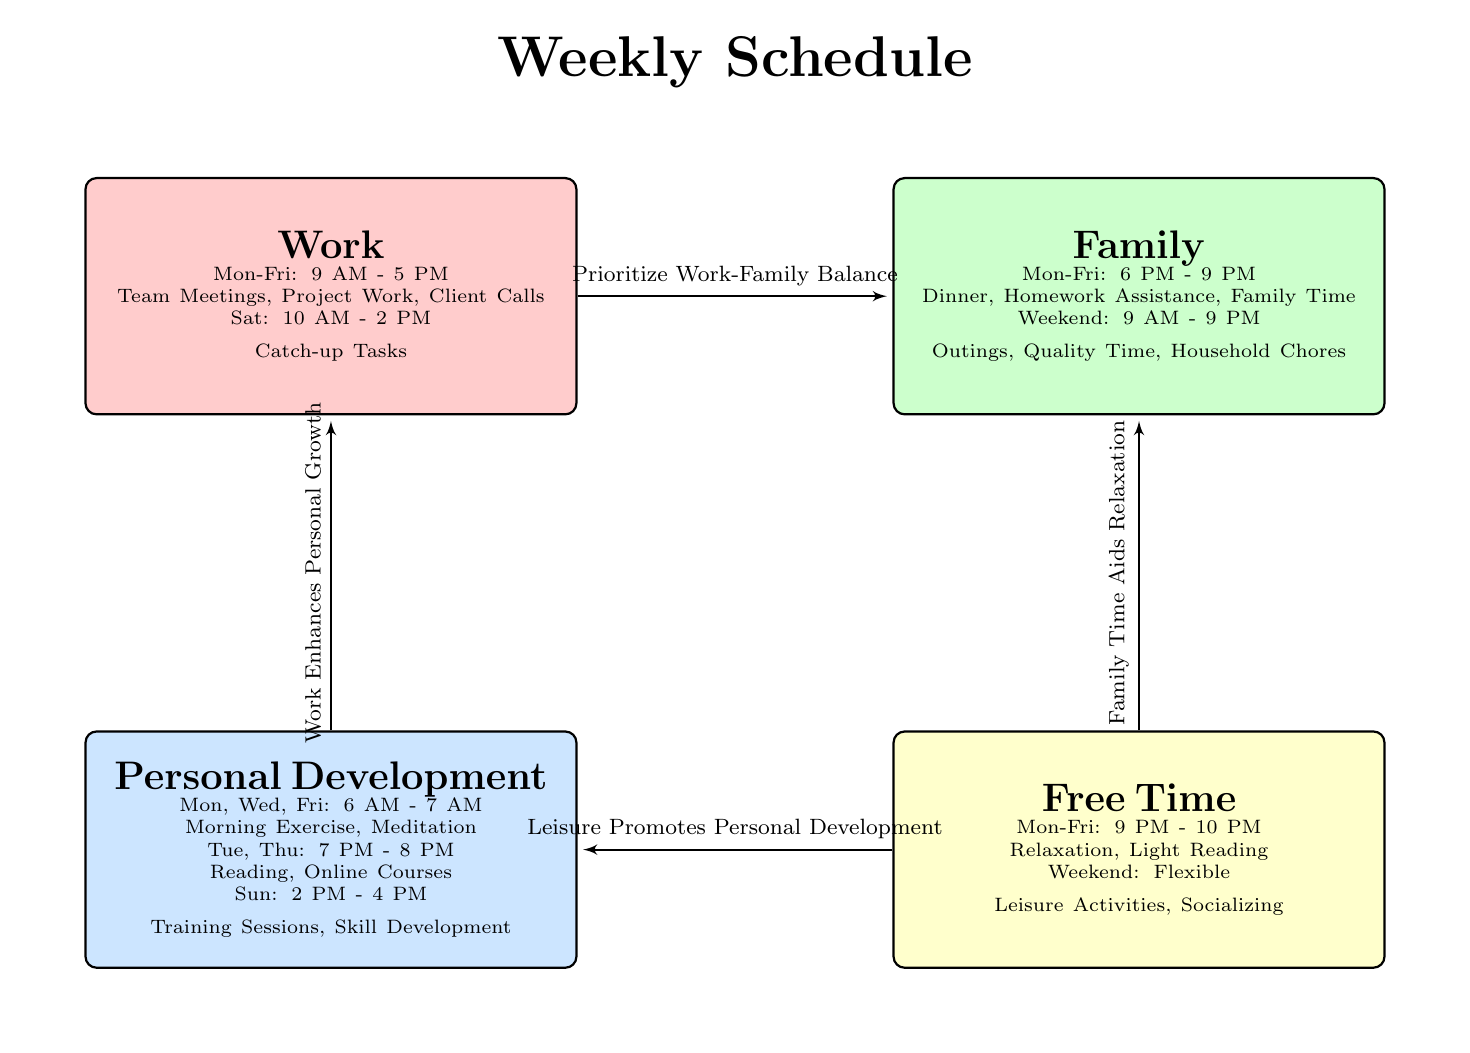What are the working hours on Saturday? The diagram states that on Saturday, the working hours are from 10 AM to 2 PM for catch-up tasks.
Answer: 10 AM - 2 PM What activities are planned for family time on weekends? The diagram lists activities for family time on weekends as outings, quality time, and household chores.
Answer: Outings, Quality Time, Household Chores How many time blocks are there in the entire schedule? The schedule consists of four distinct time blocks: Work, Family, Personal Development, and Free Time.
Answer: 4 What is the relationship between work and personal development? The diagram shows an edge labeled "Work Enhances Personal Growth" connecting the Work block to the Personal Development block, indicating a positive correlation between the two.
Answer: Work Enhances Personal Growth During which days does personal development take place in the morning? The diagram shows that personal development activities occur on Monday, Wednesday, and Friday from 6 AM to 7 AM.
Answer: Monday, Wednesday, Friday What is the main focus of the time block labeled family? The family time block emphasizes activities such as dinner, homework assistance, and family time on weekdays.
Answer: Dinner, Homework Assistance, Family Time What relaxation activities are specified for free time during the week? The diagram indicates that during the free time block from 9 PM to 10 PM on weekdays, the activities include relaxation and light reading.
Answer: Relaxation, Light Reading Which time block has the longest duration on weekends? The family time block, which spans the entire day from 9 AM to 9 PM, is the longest on weekends.
Answer: Family What is the purpose of the edge leaving from free time to personal development? The edge indicates that "Leisure Promotes Personal Development," showing that free time can help in personal growth.
Answer: Leisure Promotes Personal Development 